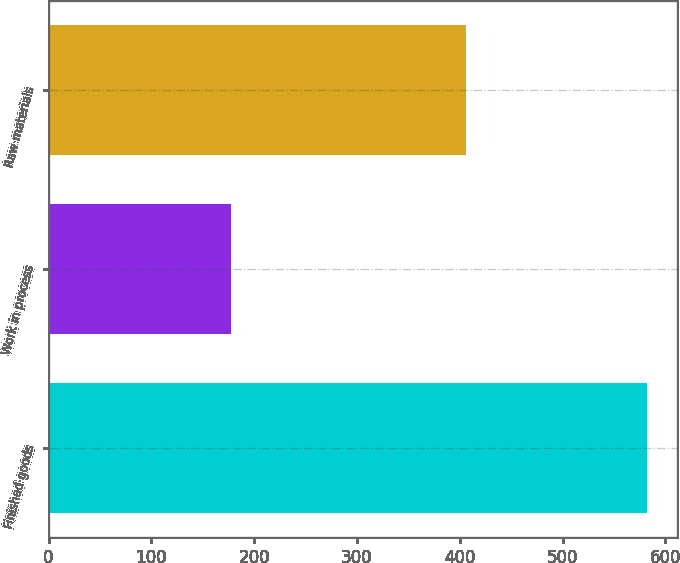Convert chart. <chart><loc_0><loc_0><loc_500><loc_500><bar_chart><fcel>Finished goods<fcel>Work in process<fcel>Raw materials<nl><fcel>581.8<fcel>177.5<fcel>406.3<nl></chart> 